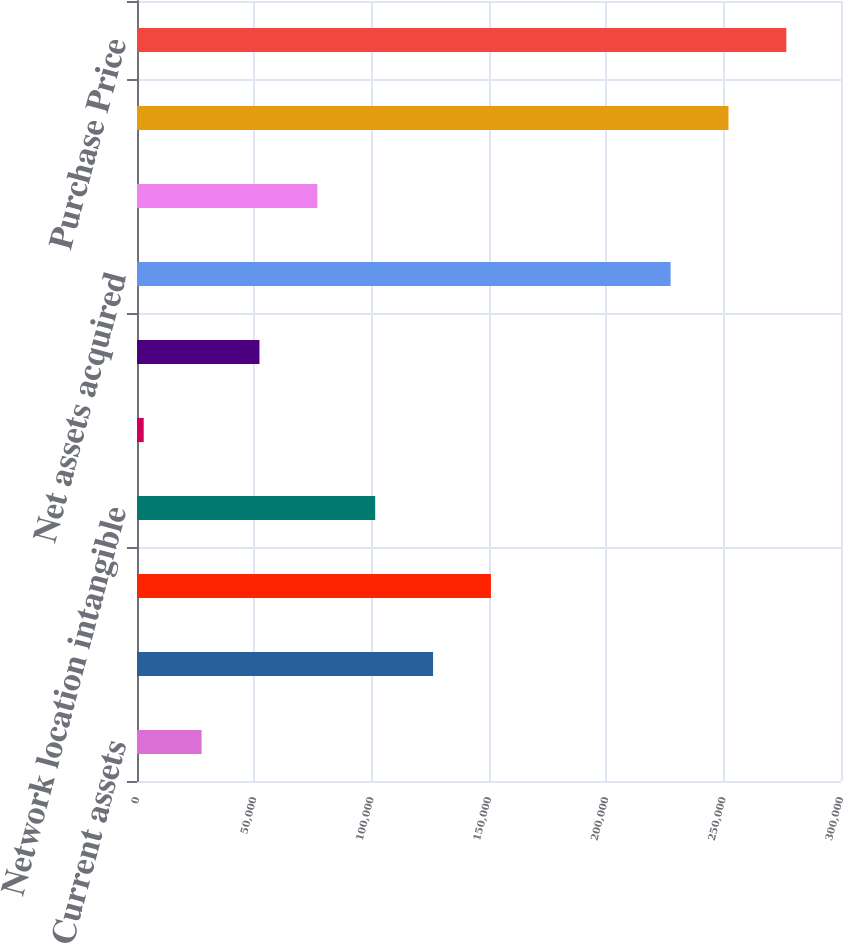<chart> <loc_0><loc_0><loc_500><loc_500><bar_chart><fcel>Current assets<fcel>Property and equipment<fcel>Intangible assets (2)<fcel>Network location intangible<fcel>Current liabilities<fcel>Other non-current liabilities<fcel>Net assets acquired<fcel>Goodwill (3)<fcel>Fair value of net assets<fcel>Purchase Price<nl><fcel>27521.1<fcel>126166<fcel>150827<fcel>101504<fcel>2860<fcel>52182.2<fcel>227391<fcel>76843.3<fcel>252052<fcel>276713<nl></chart> 